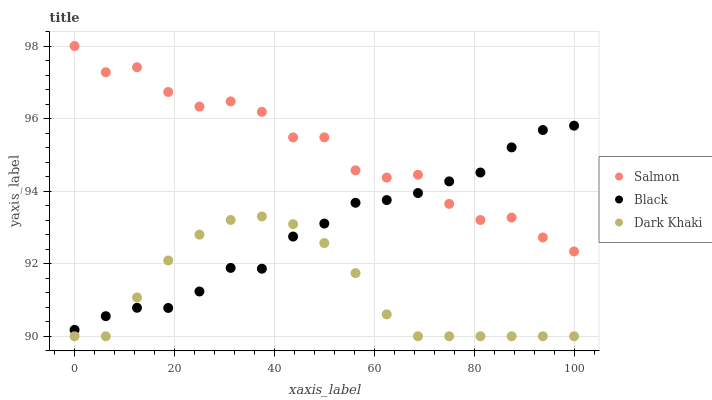Does Dark Khaki have the minimum area under the curve?
Answer yes or no. Yes. Does Salmon have the maximum area under the curve?
Answer yes or no. Yes. Does Black have the minimum area under the curve?
Answer yes or no. No. Does Black have the maximum area under the curve?
Answer yes or no. No. Is Dark Khaki the smoothest?
Answer yes or no. Yes. Is Salmon the roughest?
Answer yes or no. Yes. Is Black the smoothest?
Answer yes or no. No. Is Black the roughest?
Answer yes or no. No. Does Dark Khaki have the lowest value?
Answer yes or no. Yes. Does Black have the lowest value?
Answer yes or no. No. Does Salmon have the highest value?
Answer yes or no. Yes. Does Black have the highest value?
Answer yes or no. No. Is Dark Khaki less than Salmon?
Answer yes or no. Yes. Is Salmon greater than Dark Khaki?
Answer yes or no. Yes. Does Black intersect Salmon?
Answer yes or no. Yes. Is Black less than Salmon?
Answer yes or no. No. Is Black greater than Salmon?
Answer yes or no. No. Does Dark Khaki intersect Salmon?
Answer yes or no. No. 